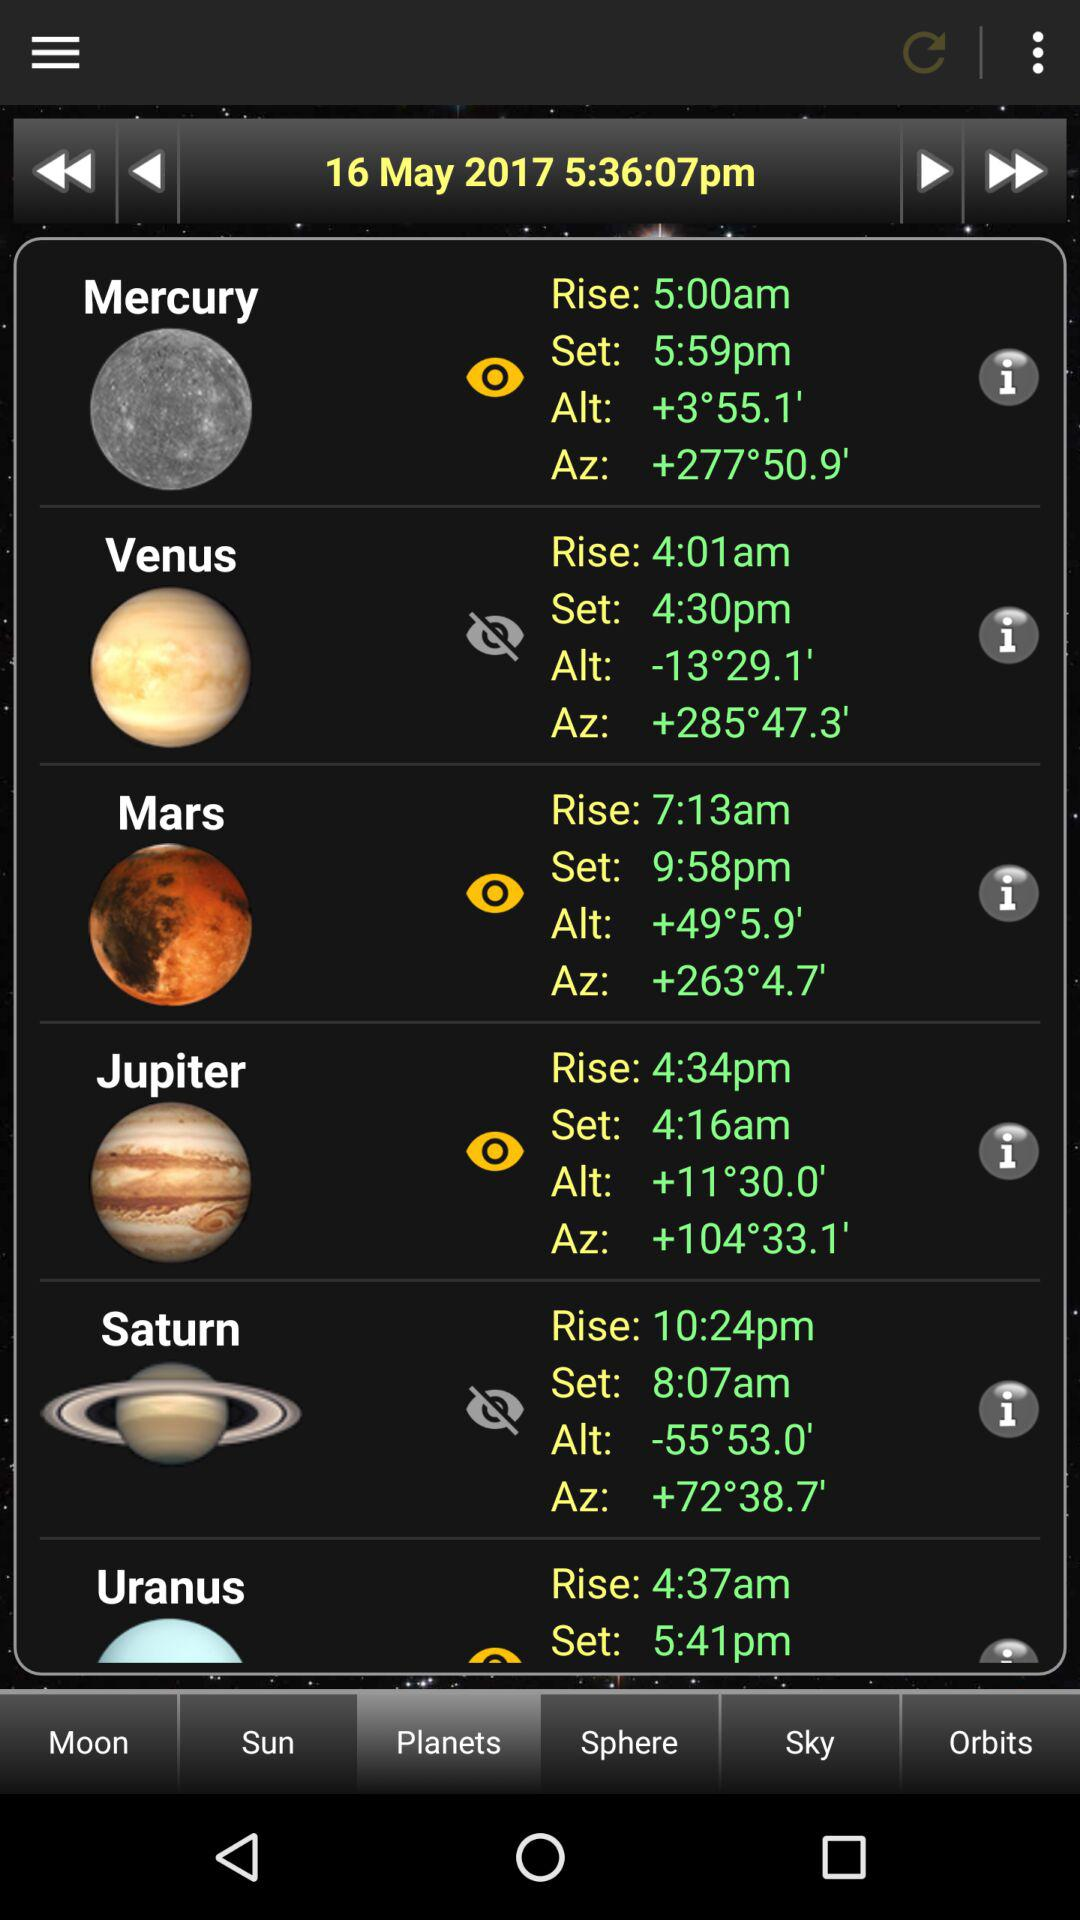What is the time? The time is 5:36:07 pm. 